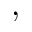<formula> <loc_0><loc_0><loc_500><loc_500>,</formula> 